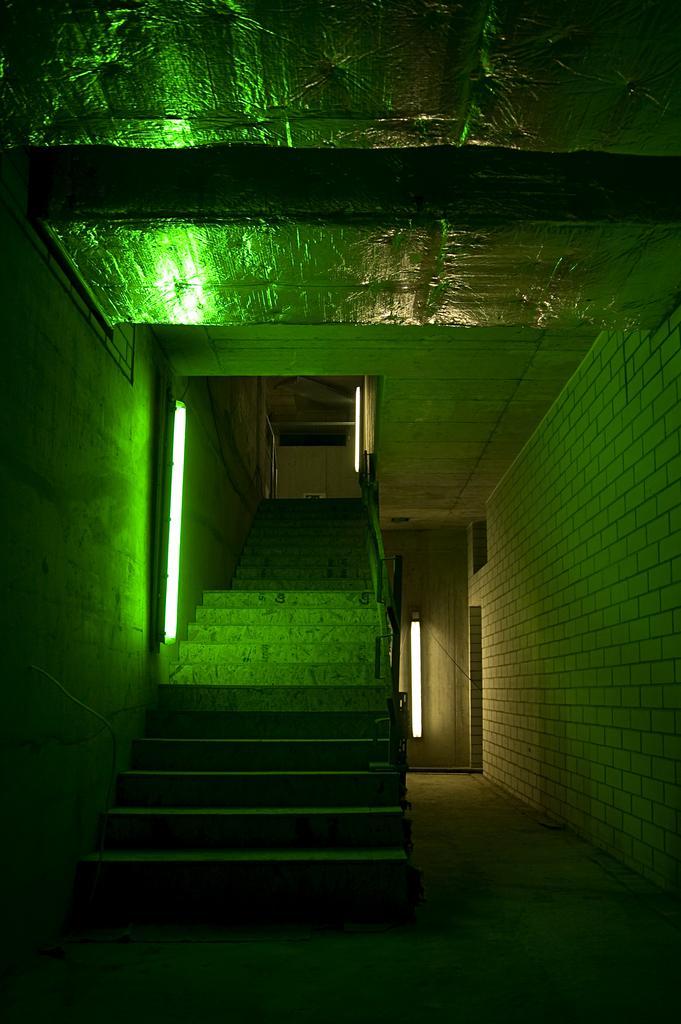Can you describe this image briefly? In this picture there is a inside view of the stairs. Beside there is a green color light. Behind there is a white door. On the top ceiling there is a aluminium foil roofing. 